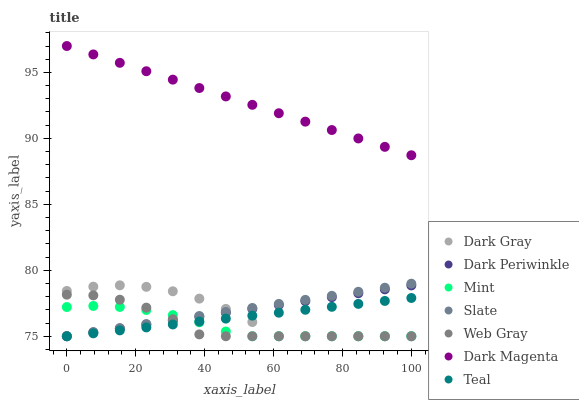Does Mint have the minimum area under the curve?
Answer yes or no. Yes. Does Dark Magenta have the maximum area under the curve?
Answer yes or no. Yes. Does Slate have the minimum area under the curve?
Answer yes or no. No. Does Slate have the maximum area under the curve?
Answer yes or no. No. Is Dark Magenta the smoothest?
Answer yes or no. Yes. Is Dark Gray the roughest?
Answer yes or no. Yes. Is Slate the smoothest?
Answer yes or no. No. Is Slate the roughest?
Answer yes or no. No. Does Web Gray have the lowest value?
Answer yes or no. Yes. Does Dark Magenta have the lowest value?
Answer yes or no. No. Does Dark Magenta have the highest value?
Answer yes or no. Yes. Does Slate have the highest value?
Answer yes or no. No. Is Mint less than Dark Magenta?
Answer yes or no. Yes. Is Dark Magenta greater than Web Gray?
Answer yes or no. Yes. Does Teal intersect Dark Gray?
Answer yes or no. Yes. Is Teal less than Dark Gray?
Answer yes or no. No. Is Teal greater than Dark Gray?
Answer yes or no. No. Does Mint intersect Dark Magenta?
Answer yes or no. No. 